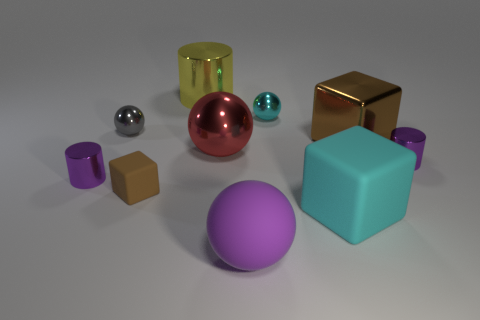Does the brown object that is in front of the red sphere have the same size as the purple shiny cylinder right of the big brown cube?
Give a very brief answer. Yes. There is a block left of the yellow cylinder; is there a purple matte thing behind it?
Offer a very short reply. No. There is a tiny gray shiny sphere; what number of cyan metallic balls are in front of it?
Provide a succinct answer. 0. How many other things are there of the same color as the large matte ball?
Make the answer very short. 2. Is the number of brown shiny things right of the brown metallic thing less than the number of large matte balls behind the big red ball?
Ensure brevity in your answer.  No. What number of things are tiny cylinders to the right of the gray shiny object or purple metallic cylinders?
Offer a terse response. 2. Is the size of the brown rubber thing the same as the brown cube behind the tiny brown rubber object?
Ensure brevity in your answer.  No. There is a metal thing that is the same shape as the big cyan matte thing; what size is it?
Provide a succinct answer. Large. What number of large metal cylinders are in front of the cyan thing that is behind the big rubber thing that is on the right side of the tiny cyan object?
Your response must be concise. 0. How many blocks are either big red objects or tiny brown things?
Offer a very short reply. 1. 